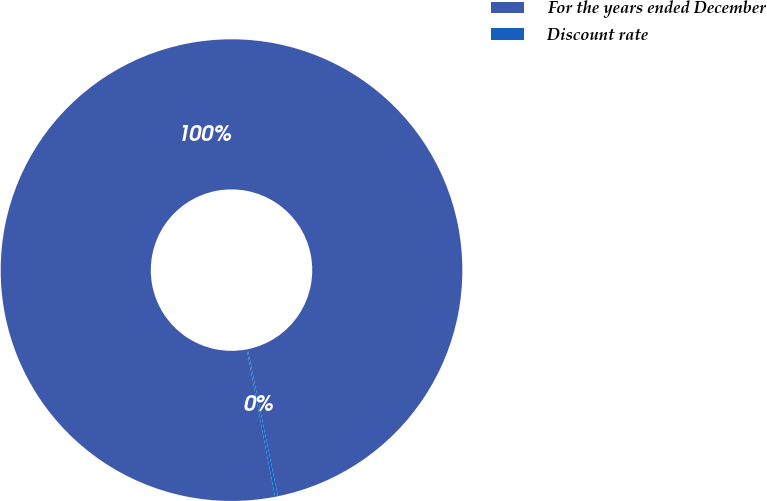<chart> <loc_0><loc_0><loc_500><loc_500><pie_chart><fcel>For the years ended December<fcel>Discount rate<nl><fcel>99.8%<fcel>0.2%<nl></chart> 